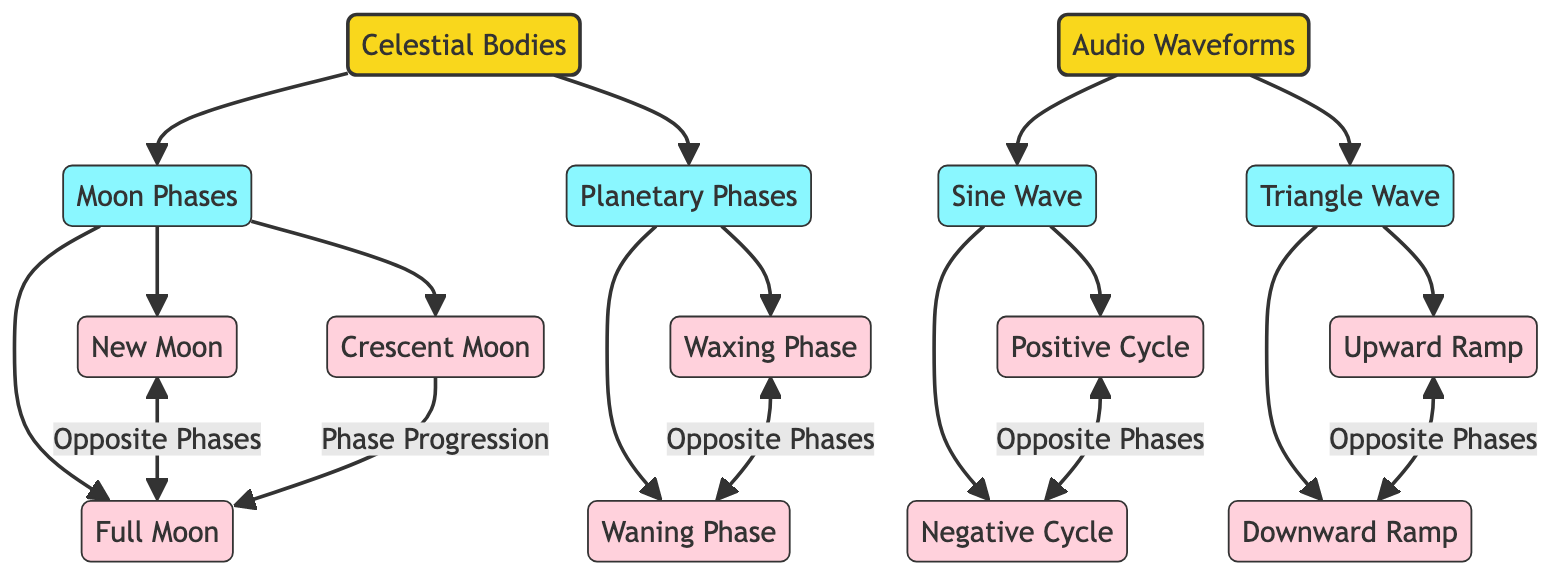What are the main categories in the diagram? The diagram has two main categories: Celestial Bodies and Audio Waveforms. These are the highest-level nodes and represent the broad areas of comparison in the diagram.
Answer: Celestial Bodies, Audio Waveforms How many phases are listed under Moon Phases? Under Moon Phases, there are three listed phases: New Moon, Full Moon, and Crescent Moon. Counting these gives a total of three phases.
Answer: 3 What is the relationship between waxing phase and waning phase? The waxing phase and waning phase are indicated as opposite phases, suggesting a contrasting relationship between these two states.
Answer: Opposite Phases Which celestial phase connects to the Full Moon? The Crescent Moon connects to the Full Moon through a phase progression, indicating a transition or progression towards the Full Moon state.
Answer: Crescent Moon How many types of waveforms are mentioned in the diagram? The diagram mentions two types of waveforms: Sine Wave and Triangle Wave. These represent the categories under the Audio Waveforms section.
Answer: 2 What are the two opposite phases of the Sine Wave? The two opposite phases of the Sine Wave are Positive Cycle and Negative Cycle, which are explicitly stated as having an opposite relationship in the diagram.
Answer: Positive Cycle, Negative Cycle Which phase does the Waxing Phase relate to? The Waxing Phase relates to the Waning Phase, as they are marked as opposite phases in the diagram, signifying their contrasting nature.
Answer: Waning Phase What kind of relationship do triangle upward and triangle downward waves have? Triangle upward and triangle downward waves are also indicated as opposing phases, just like the other waveforms and celestial phases.
Answer: Opposite Phases Which entity is a subcategory of Celestial Bodies? A subcategory of Celestial Bodies is Moon Phases, which denotes the specific types of phases defined under the celestial category.
Answer: Moon Phases 